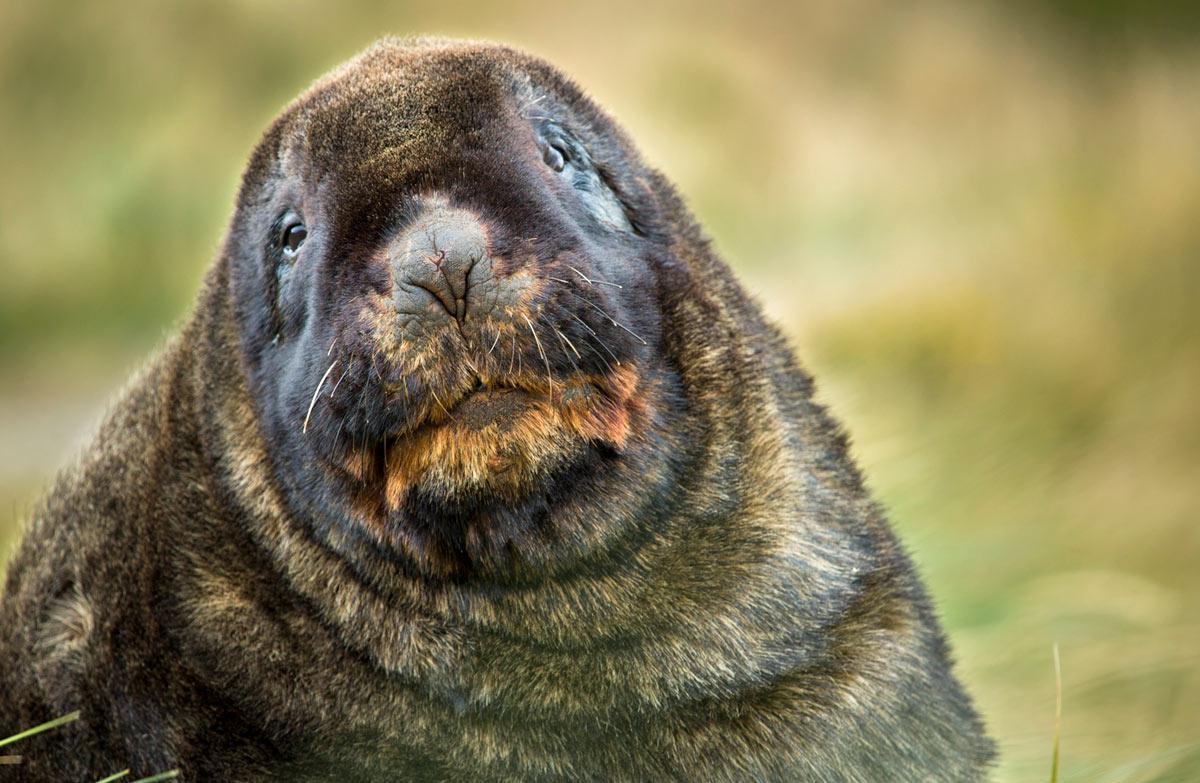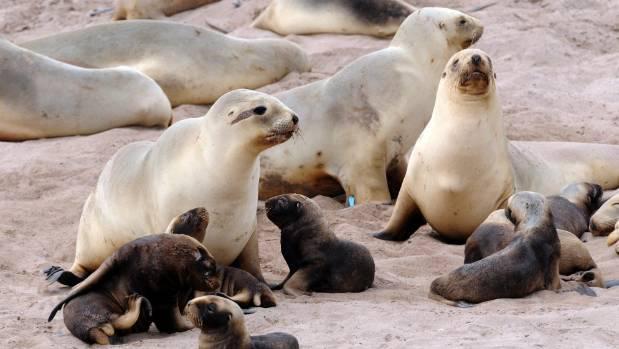The first image is the image on the left, the second image is the image on the right. Evaluate the accuracy of this statement regarding the images: "A single animal is looking toward the camera in the image on the left.". Is it true? Answer yes or no. Yes. The first image is the image on the left, the second image is the image on the right. Considering the images on both sides, is "In the foreground of an image, a left-facing small dark seal has its nose close to a bigger, paler seal." valid? Answer yes or no. Yes. 